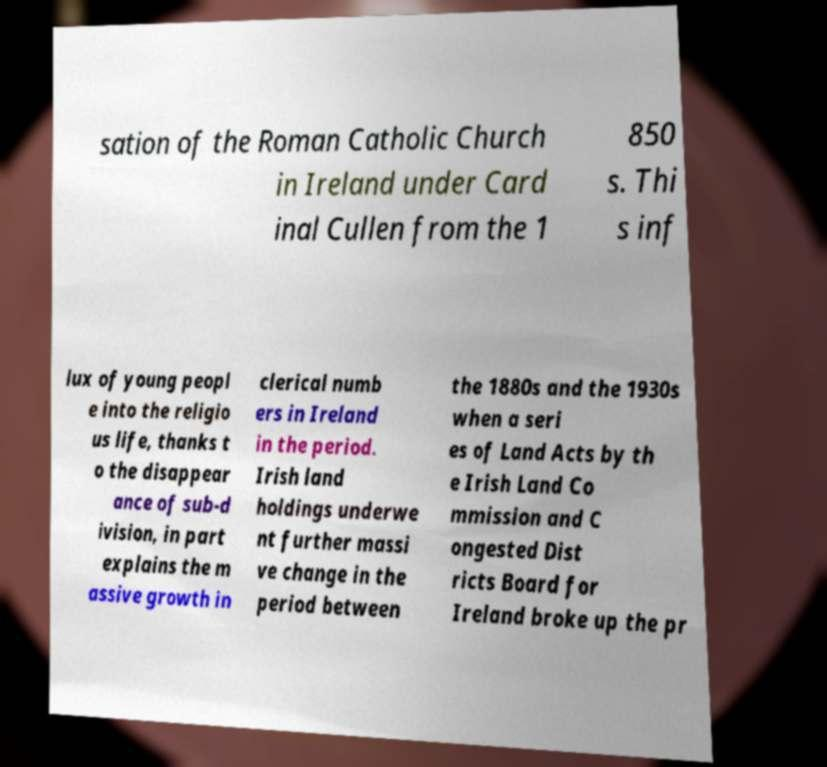What messages or text are displayed in this image? I need them in a readable, typed format. sation of the Roman Catholic Church in Ireland under Card inal Cullen from the 1 850 s. Thi s inf lux of young peopl e into the religio us life, thanks t o the disappear ance of sub-d ivision, in part explains the m assive growth in clerical numb ers in Ireland in the period. Irish land holdings underwe nt further massi ve change in the period between the 1880s and the 1930s when a seri es of Land Acts by th e Irish Land Co mmission and C ongested Dist ricts Board for Ireland broke up the pr 